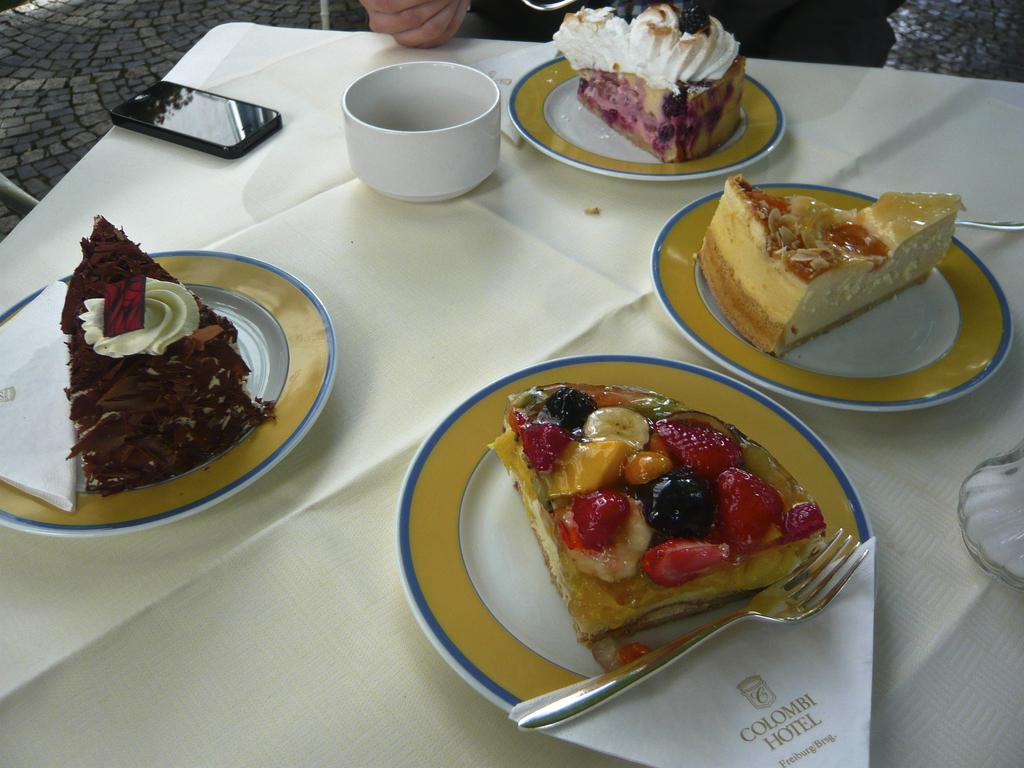What electronic device is visible in the image? There is a mobile phone in the image. What type of container is present in the image? There is a bowl in the image. What other type of container is present in the image? There is a glass product in the image. How many plates are on the table in the image? There are five plates on a table. What is on each plate in the image? Each plate has a piece of cake on it. What type of acoustics can be heard from the board in the image? There is no board present in the image, and therefore no acoustics can be heard. Who is the partner of the person holding the mobile phone in the image? There is no person holding a mobile phone in the image, and therefore no partner is present. 